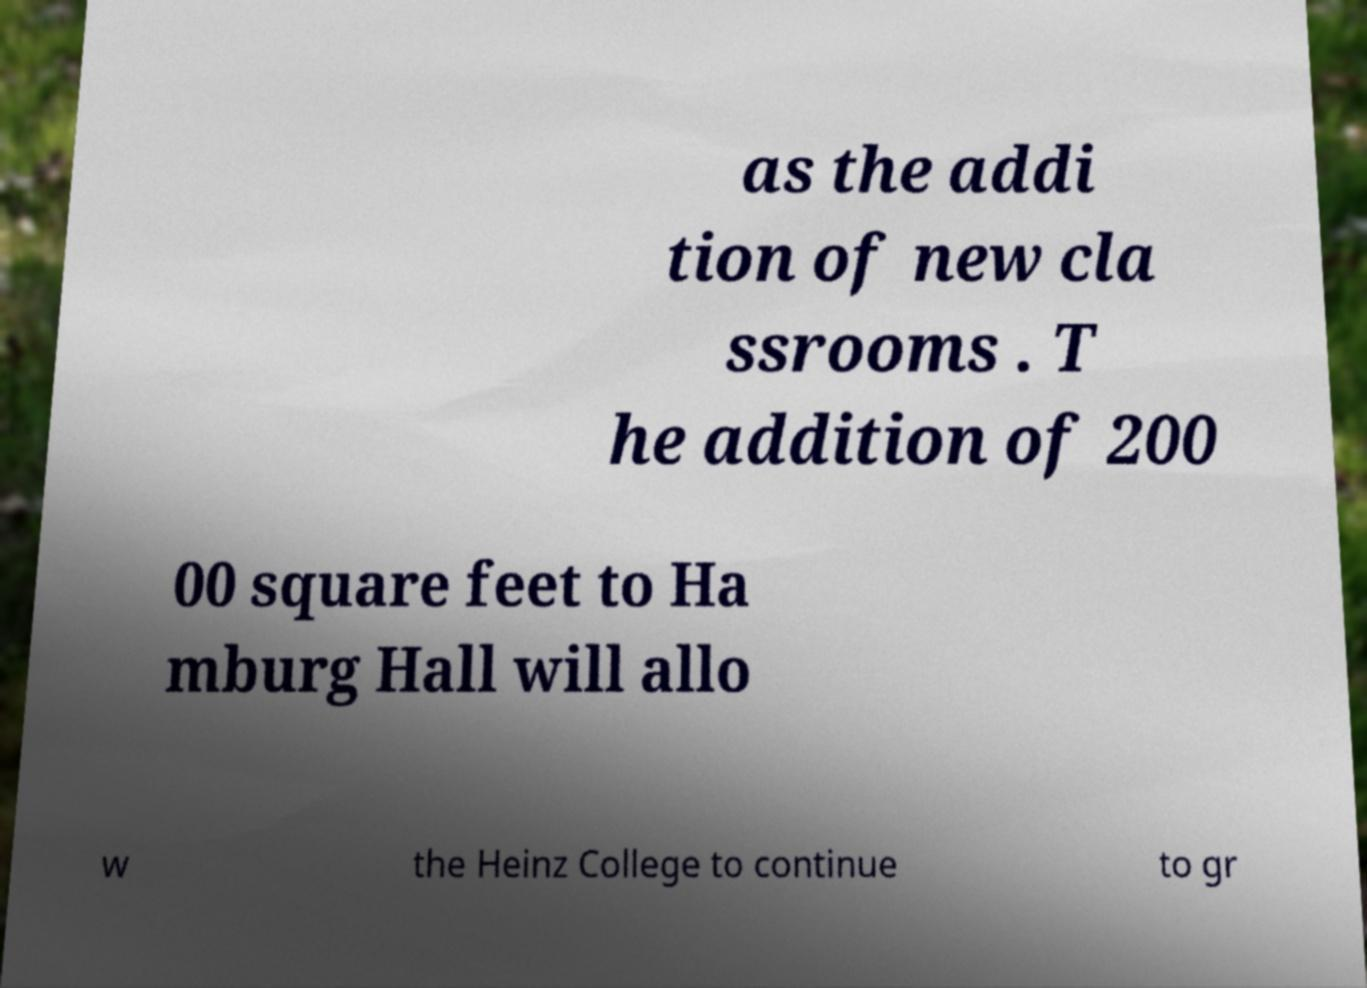Could you extract and type out the text from this image? as the addi tion of new cla ssrooms . T he addition of 200 00 square feet to Ha mburg Hall will allo w the Heinz College to continue to gr 